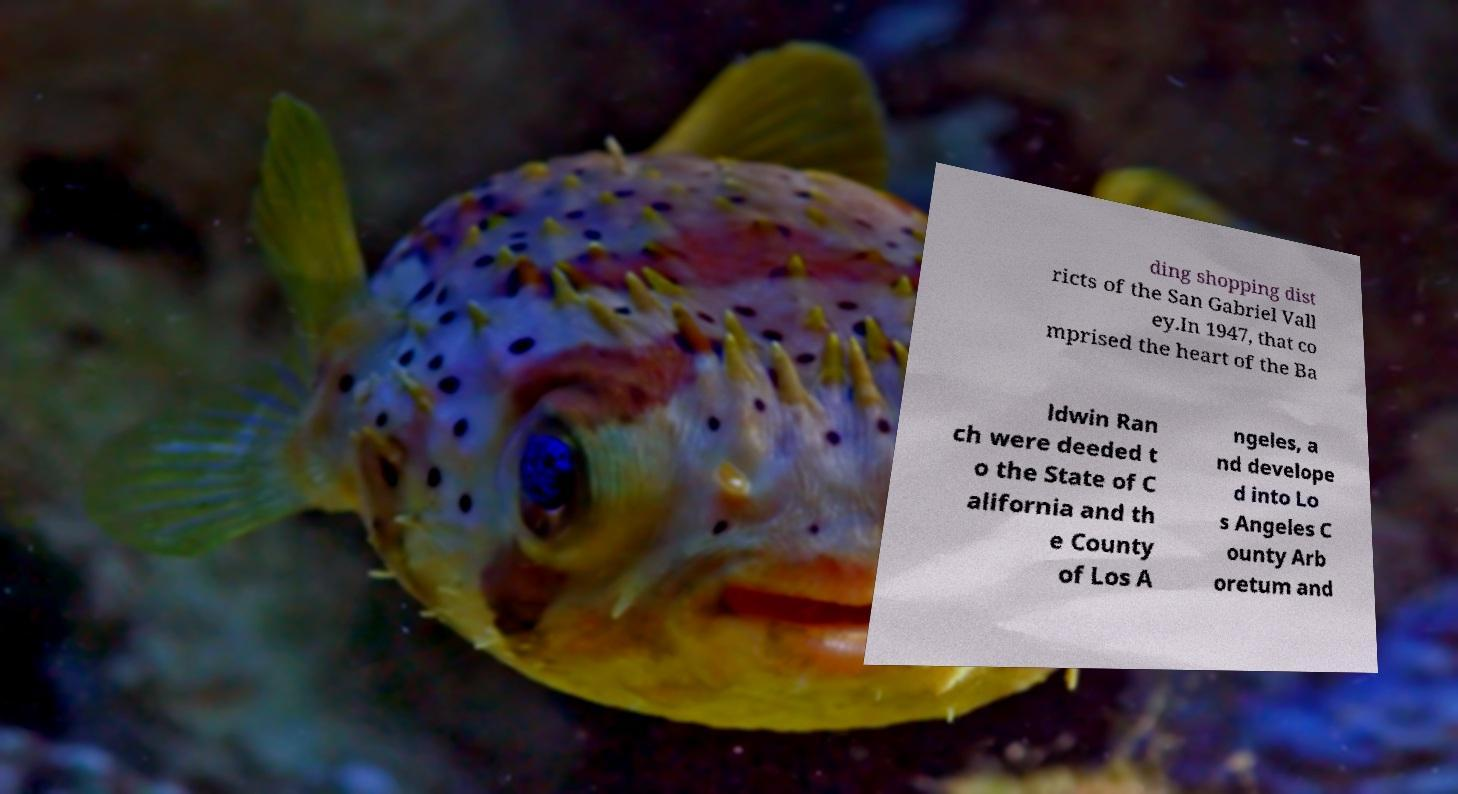There's text embedded in this image that I need extracted. Can you transcribe it verbatim? ding shopping dist ricts of the San Gabriel Vall ey.In 1947, that co mprised the heart of the Ba ldwin Ran ch were deeded t o the State of C alifornia and th e County of Los A ngeles, a nd develope d into Lo s Angeles C ounty Arb oretum and 